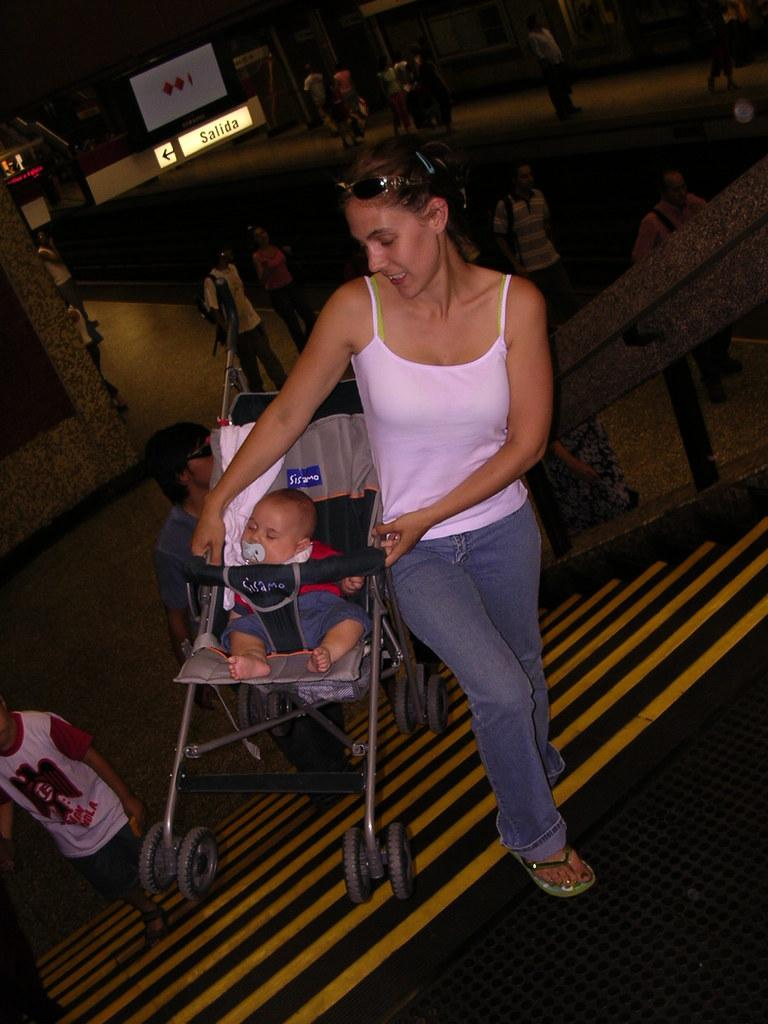Provide a one-sentence caption for the provided image. the word salida that is near a person. 